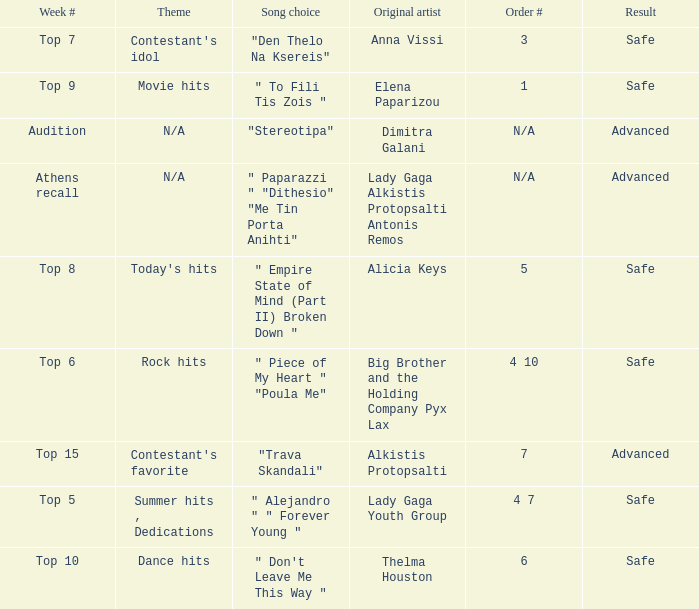Which week had the song choice " empire state of mind (part ii) broken down "? Top 8. 